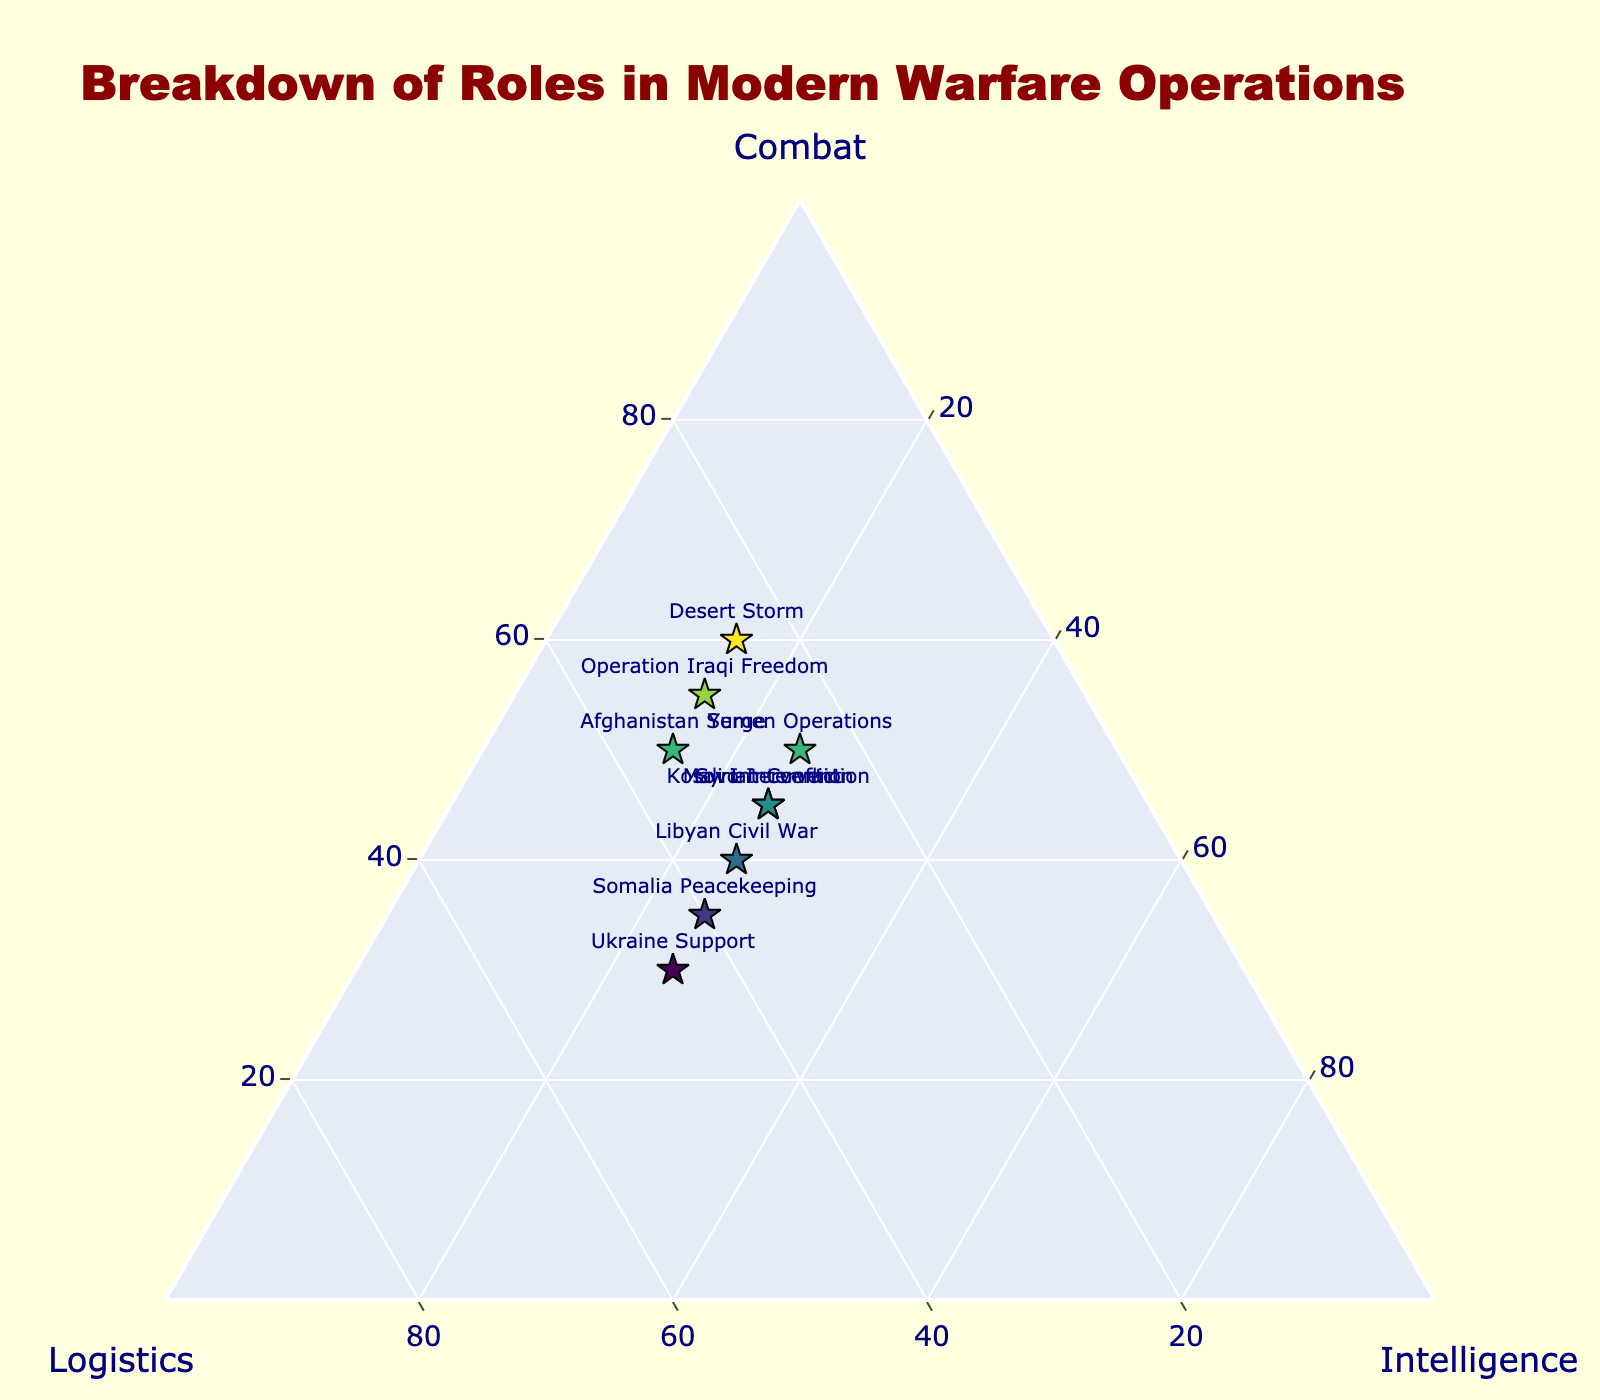What's the title of the plot? The title of the plot is displayed prominently at the top in large font. It tells the viewer the subject of the figure.
Answer: Breakdown of Roles in Modern Warfare Operations Which operation has the highest focus on combat roles? By observing the positions and colors of the data points, the operation with the highest combat percentage appears most aligned with the 'Combat' axis and has the darkest color.
Answer: Desert Storm What is the average combat percentage across all operations? Sum the combat percentages for each operation and divide by the total number of operations: (60 + 55 + 50 + 45 + 40 + 45 + 50 + 35 + 45 + 30)/10.
Answer: 45 Which operation allocates the most resources to logistics? Identify the data point closest to the 'Logistics' axis, which should be vertically aligned the most significant percentage for logistics.
Answer: Ukraine Support Compare the logistics allocations in Afghanistan Surge and Operation Iraqi Freedom. Which is higher? Locate both data points and compare their positions relative to the 'Logistics' axis. Note that Afghanistan Surge is at 35%, while Operation Iraqi Freedom is at 30%.
Answer: Afghanistan Surge Which two operations have an equal percentage allocation for intelligence roles? Look for data points with the same 'Intelligence' axis position. Operations with equal positions are compared to find an equal percentage in intelligence.
Answer: Operation Iraqi Freedom and Afghanistan Surge (both 15%) How does the intelligence allocation in Syrian Conflict compare to Yemen Operations? Look at the data points corresponding to these operations and compare their positions on the 'Intelligence' axis. Both are at 25%.
Answer: Equal What's the combined logistics and intelligence percentage for Somalia Peacekeeping? Add the percentages of logistics and intelligence for Somalia Peacekeeping: 40 (logistics) + 25 (intelligence).
Answer: 65% Which operation is most balanced across combat, logistics, and intelligence roles? Look for a data point near the center of the plot, indicating similar percentages for all three roles.
Answer: Somali Peacekeeping What is the percentage difference in combat roles between Desert Storm and Ukraine Support? Subtract the combat percentage of Ukraine Support from Desert Storm: 60% (Desert Storm) - 30% (Ukraine Support).
Answer: 30% 